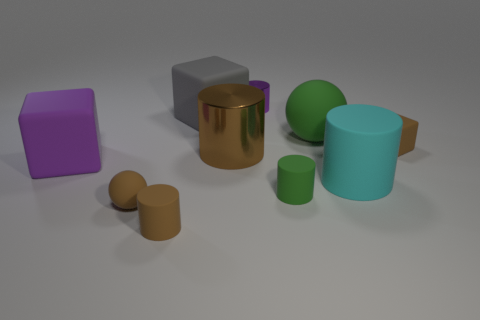How big is the brown rubber sphere?
Make the answer very short. Small. How many other objects are there of the same color as the big metal thing?
Ensure brevity in your answer.  3. Is the shape of the tiny brown matte thing to the right of the big sphere the same as  the big green matte object?
Offer a terse response. No. What is the color of the other metallic thing that is the same shape as the large brown metal thing?
Make the answer very short. Purple. Is there anything else that has the same material as the big green thing?
Keep it short and to the point. Yes. There is a brown matte object that is the same shape as the big green thing; what size is it?
Keep it short and to the point. Small. There is a tiny thing that is both in front of the gray thing and behind the large cyan cylinder; what material is it?
Give a very brief answer. Rubber. There is a sphere behind the big metallic object; is it the same color as the tiny ball?
Your answer should be very brief. No. There is a big ball; does it have the same color as the cube behind the small brown cube?
Keep it short and to the point. No. Are there any objects behind the tiny purple metal cylinder?
Your answer should be very brief. No. 